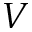<formula> <loc_0><loc_0><loc_500><loc_500>V</formula> 